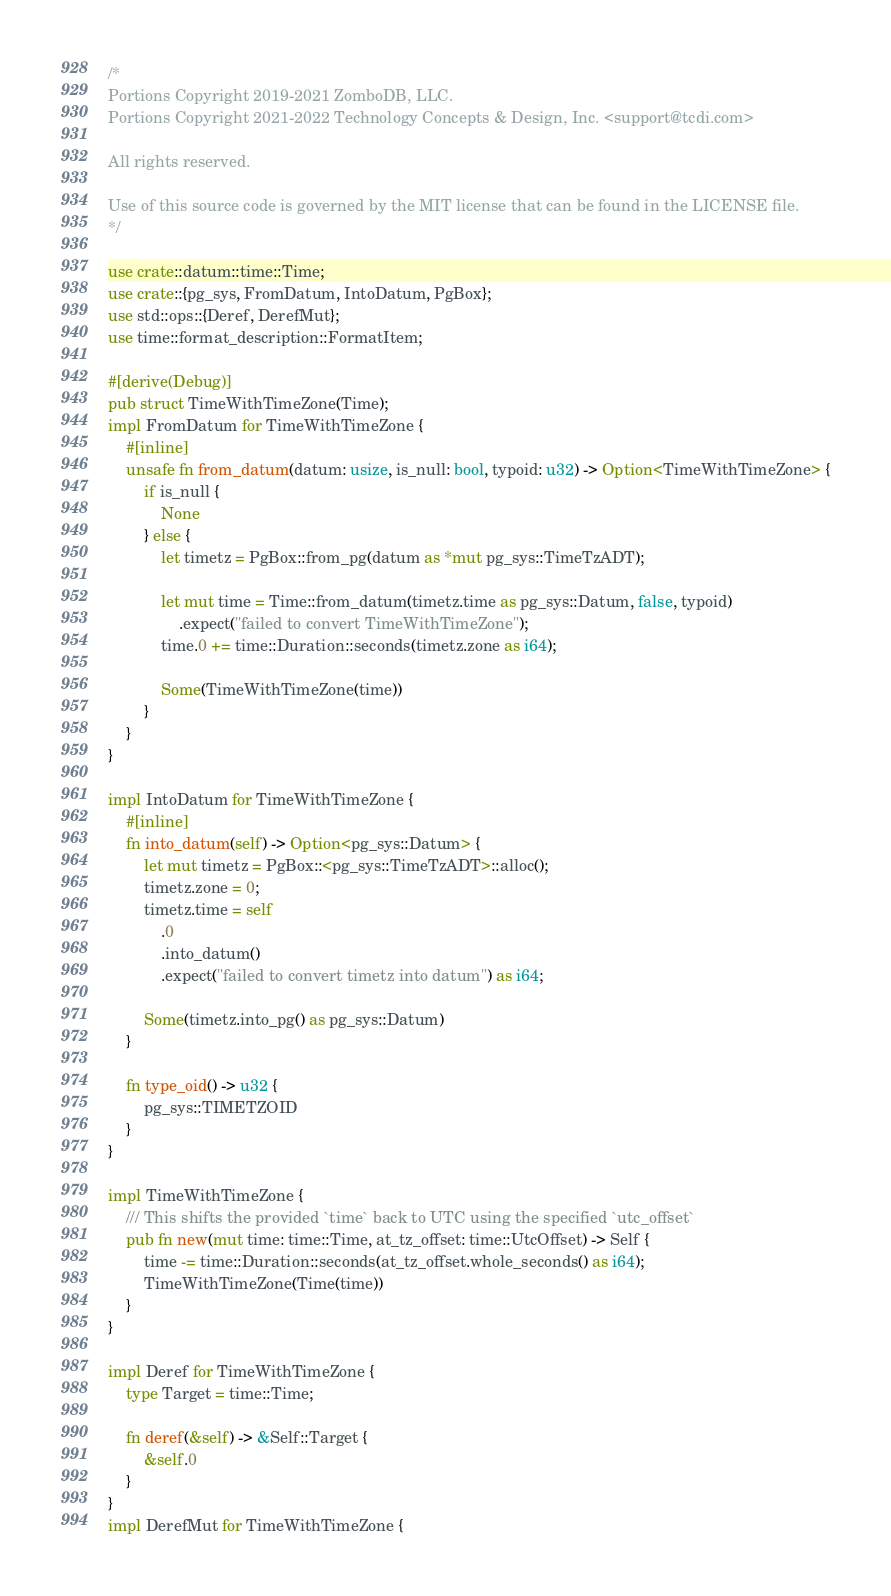Convert code to text. <code><loc_0><loc_0><loc_500><loc_500><_Rust_>/*
Portions Copyright 2019-2021 ZomboDB, LLC.
Portions Copyright 2021-2022 Technology Concepts & Design, Inc. <support@tcdi.com>

All rights reserved.

Use of this source code is governed by the MIT license that can be found in the LICENSE file.
*/

use crate::datum::time::Time;
use crate::{pg_sys, FromDatum, IntoDatum, PgBox};
use std::ops::{Deref, DerefMut};
use time::format_description::FormatItem;

#[derive(Debug)]
pub struct TimeWithTimeZone(Time);
impl FromDatum for TimeWithTimeZone {
    #[inline]
    unsafe fn from_datum(datum: usize, is_null: bool, typoid: u32) -> Option<TimeWithTimeZone> {
        if is_null {
            None
        } else {
            let timetz = PgBox::from_pg(datum as *mut pg_sys::TimeTzADT);

            let mut time = Time::from_datum(timetz.time as pg_sys::Datum, false, typoid)
                .expect("failed to convert TimeWithTimeZone");
            time.0 += time::Duration::seconds(timetz.zone as i64);

            Some(TimeWithTimeZone(time))
        }
    }
}

impl IntoDatum for TimeWithTimeZone {
    #[inline]
    fn into_datum(self) -> Option<pg_sys::Datum> {
        let mut timetz = PgBox::<pg_sys::TimeTzADT>::alloc();
        timetz.zone = 0;
        timetz.time = self
            .0
            .into_datum()
            .expect("failed to convert timetz into datum") as i64;

        Some(timetz.into_pg() as pg_sys::Datum)
    }

    fn type_oid() -> u32 {
        pg_sys::TIMETZOID
    }
}

impl TimeWithTimeZone {
    /// This shifts the provided `time` back to UTC using the specified `utc_offset`
    pub fn new(mut time: time::Time, at_tz_offset: time::UtcOffset) -> Self {
        time -= time::Duration::seconds(at_tz_offset.whole_seconds() as i64);
        TimeWithTimeZone(Time(time))
    }
}

impl Deref for TimeWithTimeZone {
    type Target = time::Time;

    fn deref(&self) -> &Self::Target {
        &self.0
    }
}
impl DerefMut for TimeWithTimeZone {</code> 